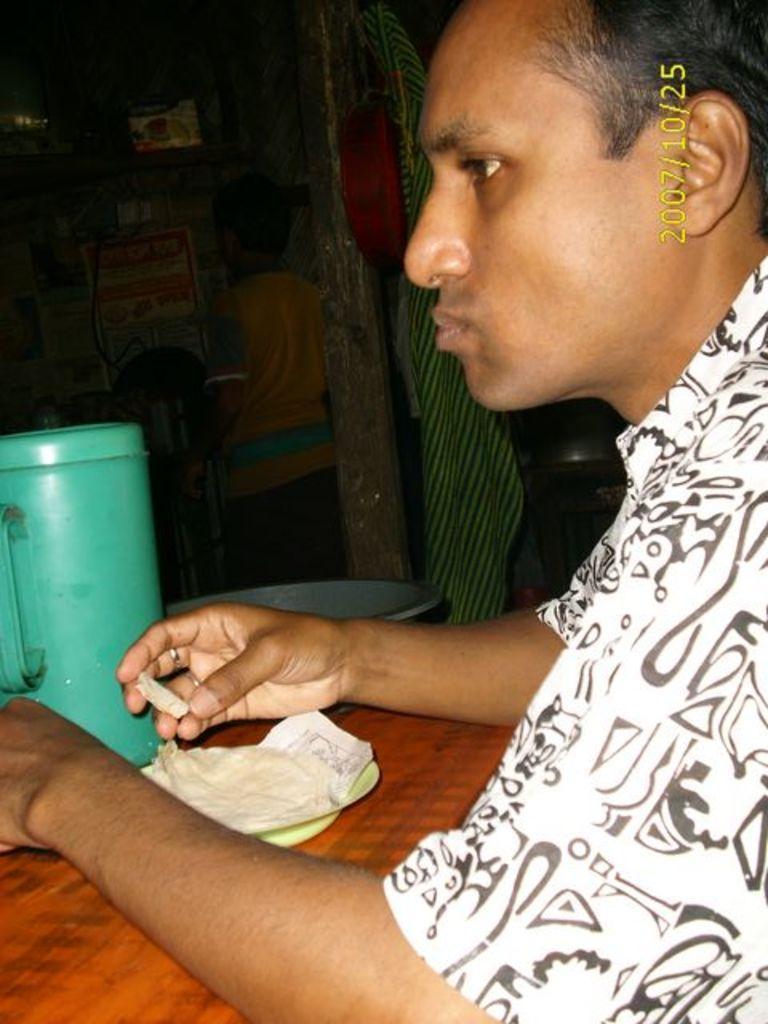How would you summarize this image in a sentence or two? In this image I see a man who is wearing a shirt which is of white and black in color and I see a table on which there is a plate and I see food on it and I see that this man is holding a piece of food in his hand and I see a green color jug over here. In the background I see a person over here and I see a thing over here and I see the watermark over here. 